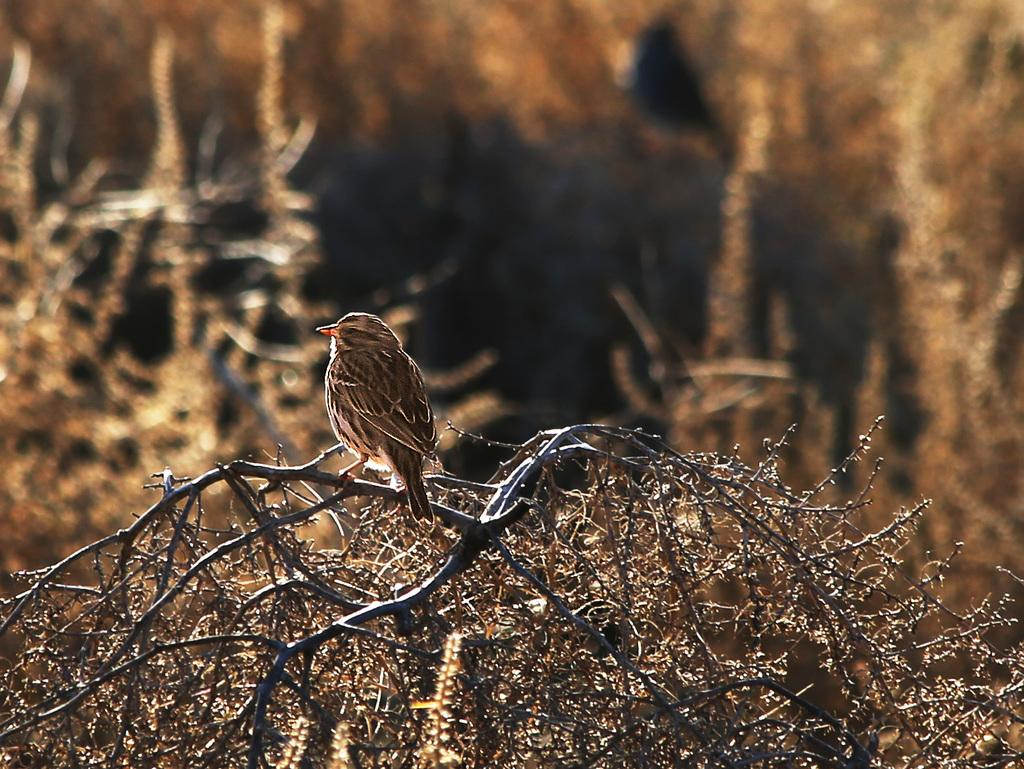What type of animal can be seen in the image? There is a bird in the image. What is the bird standing on? The bird is standing on a dry plant. What can be seen in the background of the image? There are many plants in the background of the image. What type of ball is being used for peace negotiations in the image? There is no ball or peace negotiations present in the image; it features a bird standing on a dry plant with many plants in the background. 